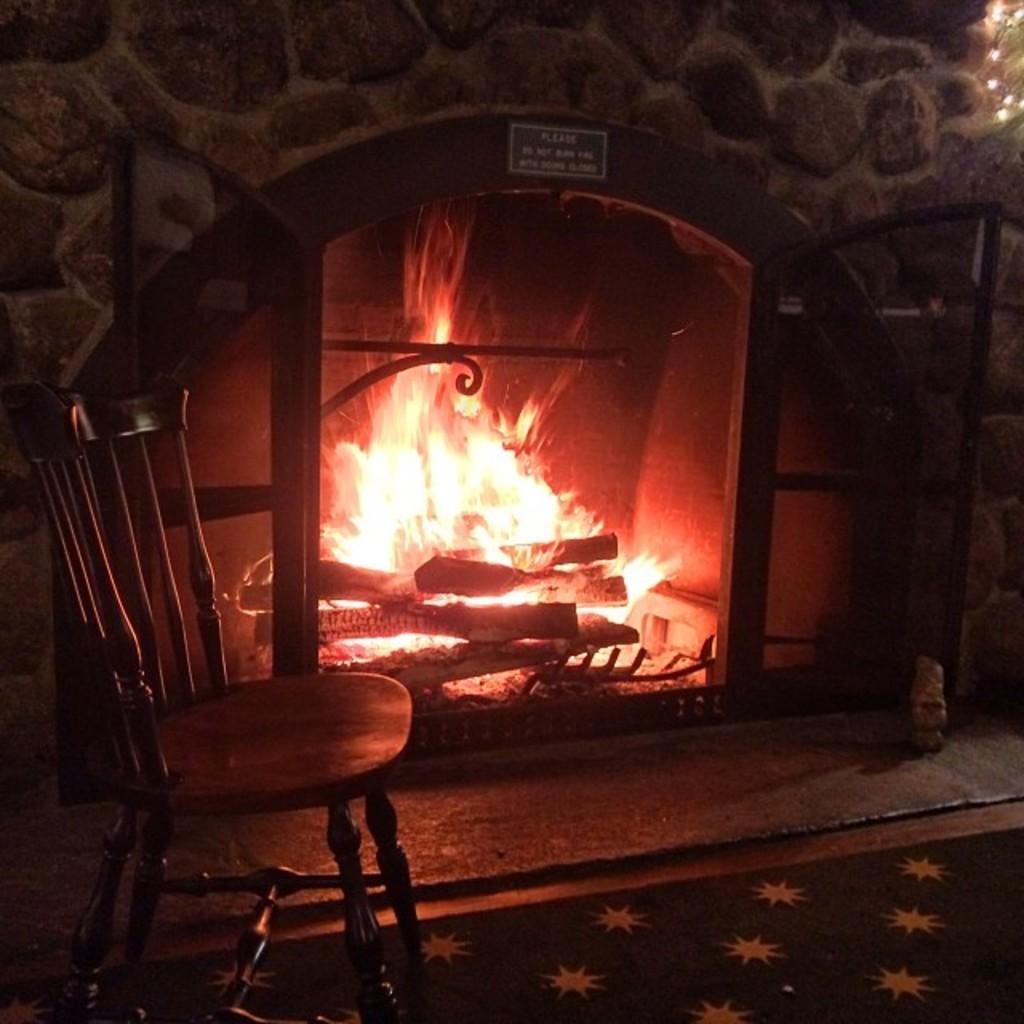Can you describe this image briefly? In this image we can see fireplace with some wood burning in it. In front of it there is a chair, and a mat, we can see a board with some text written on it. 